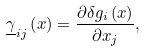Convert formula to latex. <formula><loc_0><loc_0><loc_500><loc_500>\underline { \gamma } _ { i j } \left ( x \right ) = \frac { \partial \delta g _ { i } \left ( x \right ) } { \partial x _ { j } } ,</formula> 